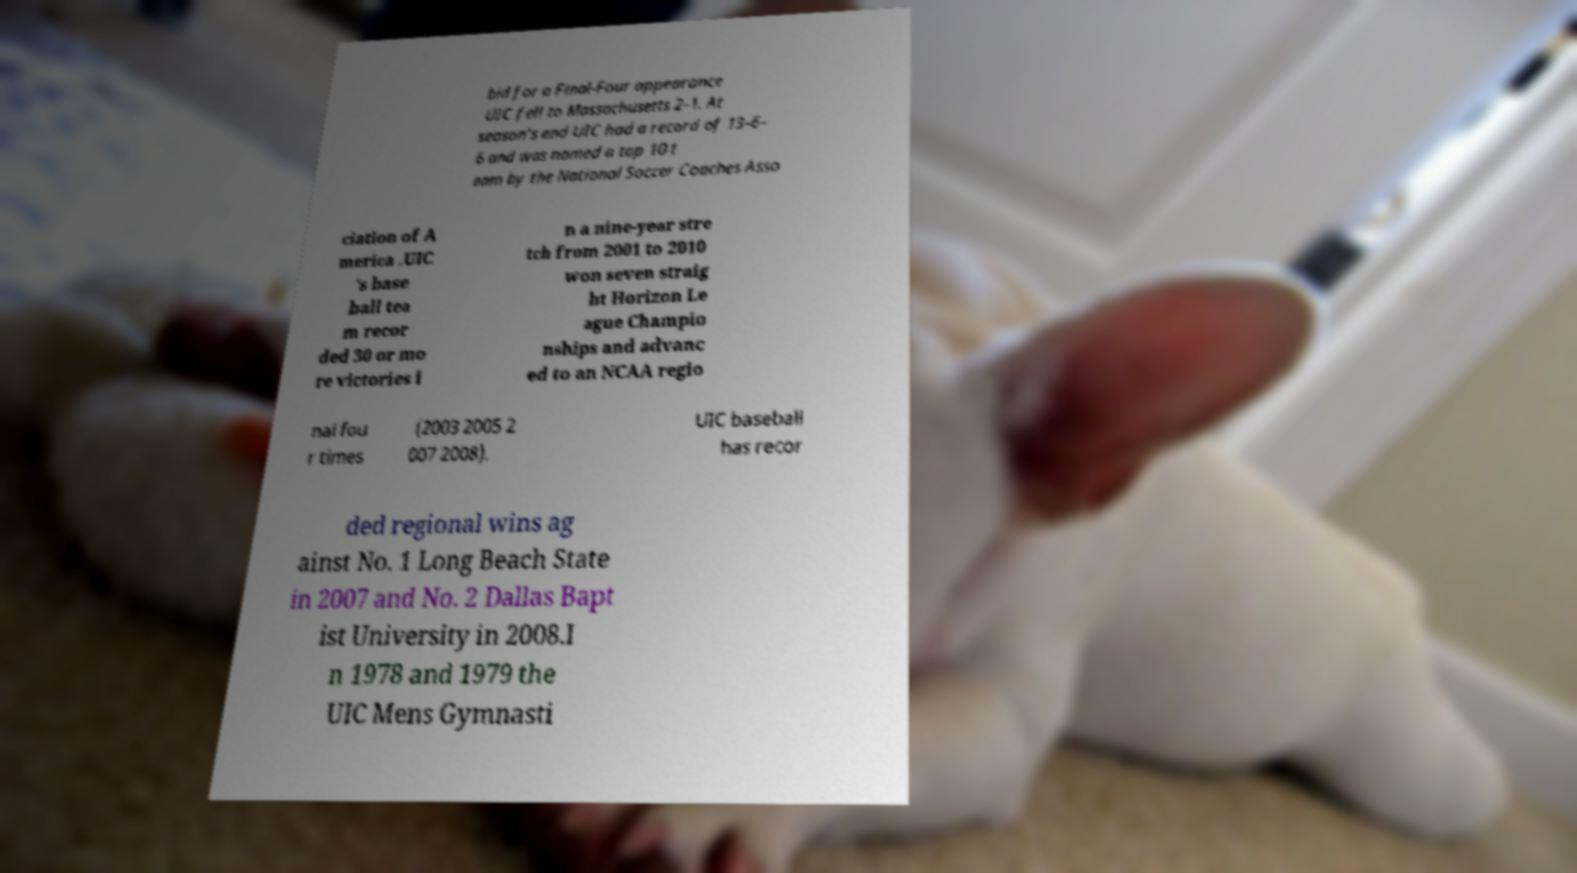Please read and relay the text visible in this image. What does it say? bid for a Final-Four appearance UIC fell to Massachusetts 2–1. At season's end UIC had a record of 13–6– 6 and was named a top 10 t eam by the National Soccer Coaches Asso ciation of A merica .UIC 's base ball tea m recor ded 30 or mo re victories i n a nine-year stre tch from 2001 to 2010 won seven straig ht Horizon Le ague Champio nships and advanc ed to an NCAA regio nal fou r times (2003 2005 2 007 2008). UIC baseball has recor ded regional wins ag ainst No. 1 Long Beach State in 2007 and No. 2 Dallas Bapt ist University in 2008.I n 1978 and 1979 the UIC Mens Gymnasti 